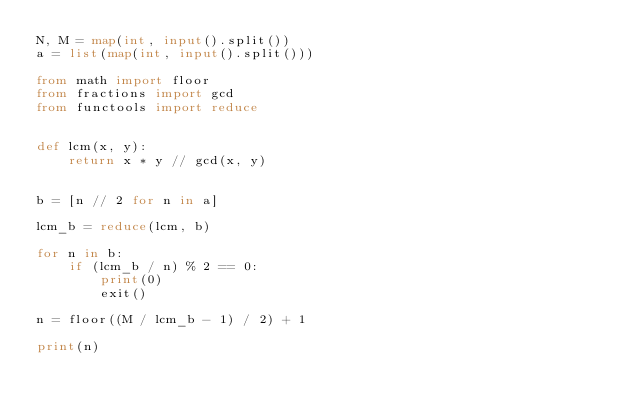<code> <loc_0><loc_0><loc_500><loc_500><_Python_>N, M = map(int, input().split())
a = list(map(int, input().split()))

from math import floor
from fractions import gcd
from functools import reduce


def lcm(x, y):
    return x * y // gcd(x, y)


b = [n // 2 for n in a]

lcm_b = reduce(lcm, b)

for n in b:
    if (lcm_b / n) % 2 == 0:
        print(0)
        exit()

n = floor((M / lcm_b - 1) / 2) + 1

print(n)
</code> 